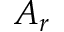<formula> <loc_0><loc_0><loc_500><loc_500>A _ { r }</formula> 